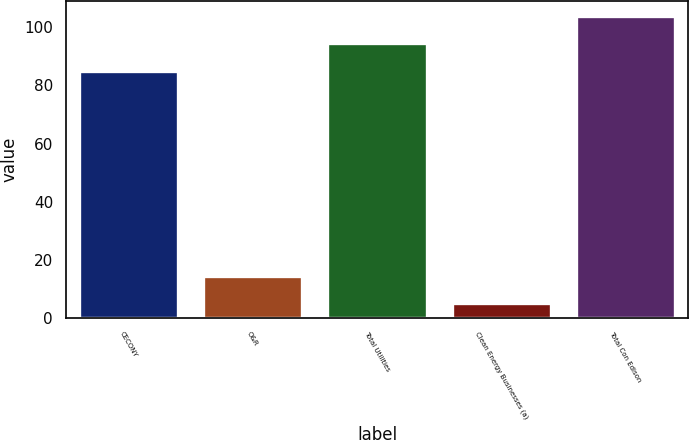Convert chart. <chart><loc_0><loc_0><loc_500><loc_500><bar_chart><fcel>CECONY<fcel>O&R<fcel>Total Utilities<fcel>Clean Energy Businesses (a)<fcel>Total Con Edison<nl><fcel>85<fcel>14.5<fcel>94.5<fcel>5<fcel>104<nl></chart> 